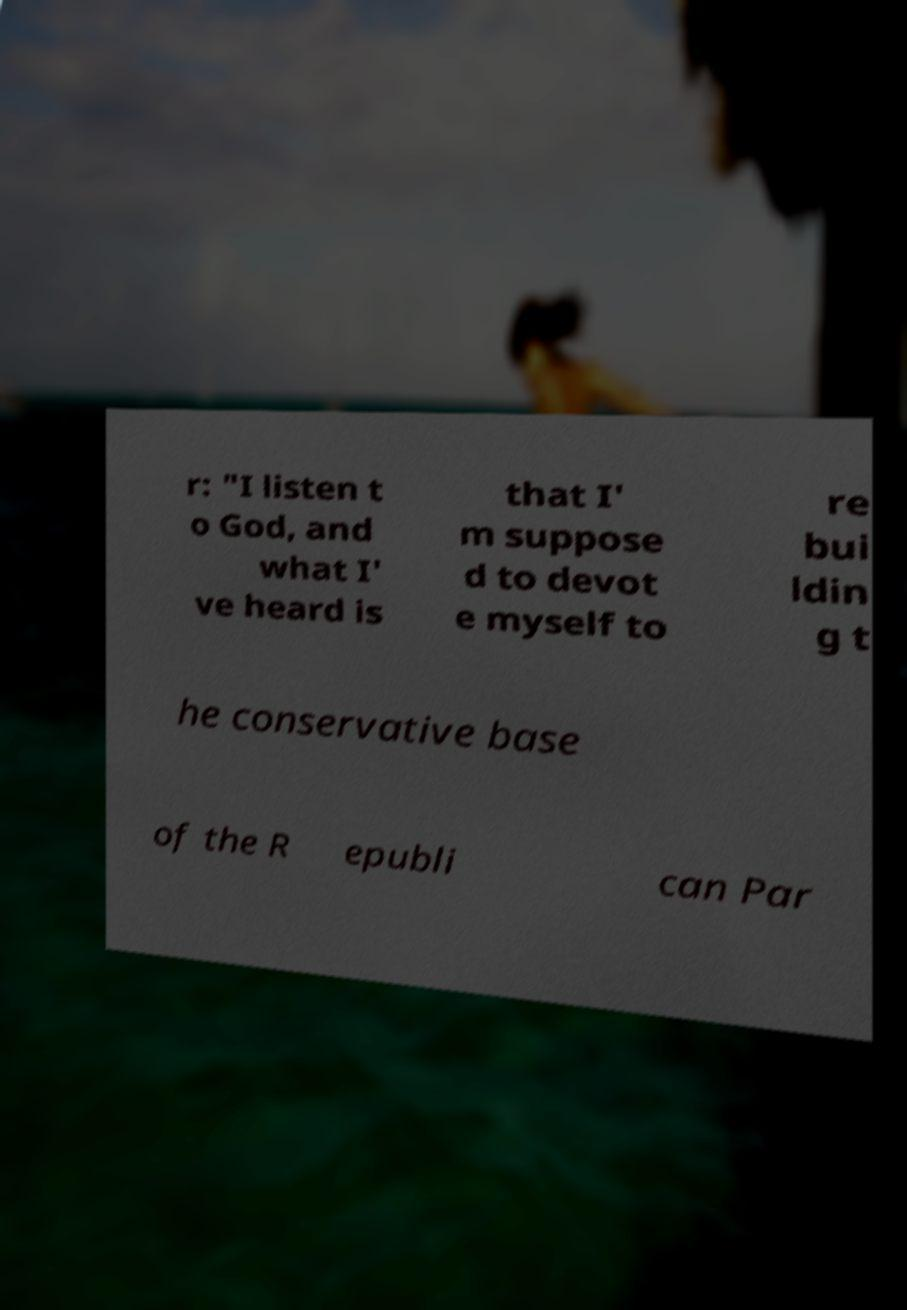Can you read and provide the text displayed in the image?This photo seems to have some interesting text. Can you extract and type it out for me? r: "I listen t o God, and what I' ve heard is that I' m suppose d to devot e myself to re bui ldin g t he conservative base of the R epubli can Par 